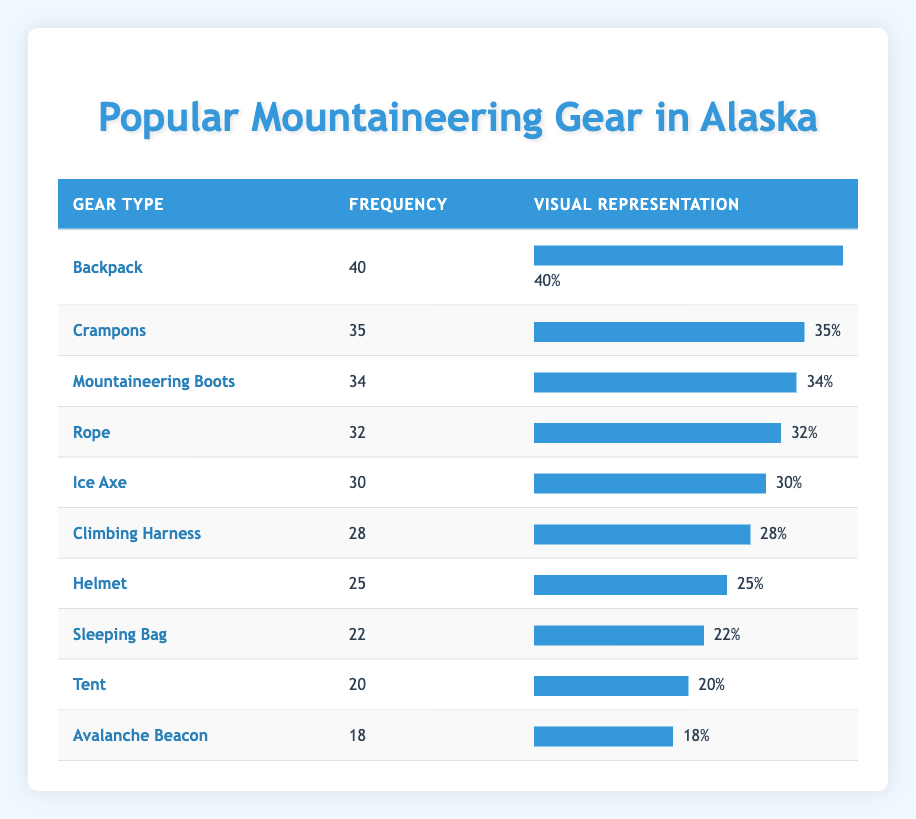What gear type has the highest frequency? By looking at the frequency column, the gear type with the highest value is "Backpack" with a frequency of 40.
Answer: Backpack What is the frequency of the Ice Axe? The Ice Axe is listed in the table with a frequency of 30.
Answer: 30 Which gear types have a frequency greater than 30? The gear types with frequency greater than 30 are: "Backpack" (40), "Crampons" (35), "Mountaineering Boots" (34), and "Rope" (32).
Answer: Backpack, Crampons, Mountaineering Boots, Rope Is the frequency of the Avalanche Beacon greater than that of the Tent? The frequency of the Avalanche Beacon is 18, while the frequency of the Tent is 20. Since 18 is less than 20, the statement is false.
Answer: No What is the total frequency of all gear types listed? To find the total frequency, we sum all the frequencies: 40 + 35 + 34 + 32 + 30 + 28 + 25 + 22 + 20 + 18 =  364. So, the total frequency of all gear types is 364.
Answer: 364 What is the difference in frequency between the Backpack and the Avalanche Beacon? The frequency of the Backpack is 40 and the Avalanche Beacon is 18. The difference is 40 - 18 = 22.
Answer: 22 Which gear type has the lowest frequency? From the table, the gear with the lowest frequency is "Avalanche Beacon" with a frequency of 18.
Answer: Avalanche Beacon What is the average frequency of the gear types listed? There are 10 gear types, and the total frequency is 364. To find the average, we divide the total by the number of gear types: 364 / 10 = 36.4.
Answer: 36.4 How many more frequencies does the Backpack have compared to the Helmet? The Backpack has a frequency of 40, while the Helmet has a frequency of 25. The difference is 40 - 25 = 15.
Answer: 15 